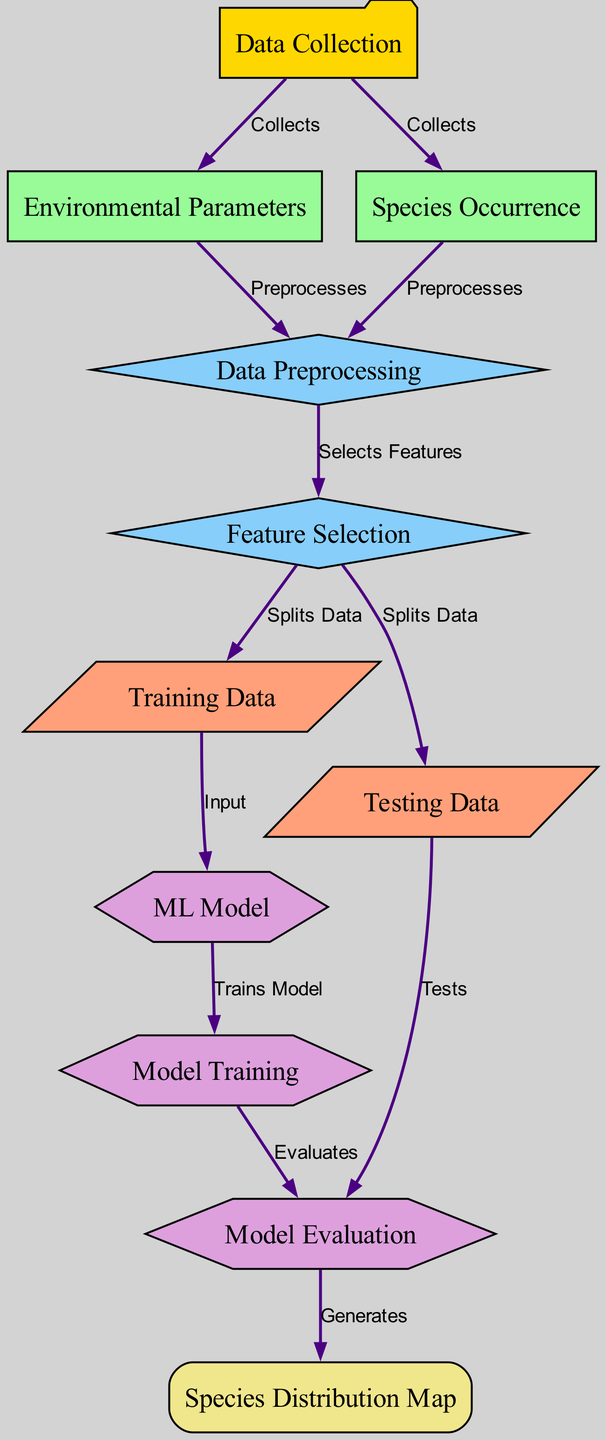What is the first step in the species distribution prediction process? According to the diagram, the first node is "Data Collection". This shows that the initial step involves gathering data before any analysis or modeling can occur.
Answer: Data Collection How many nodes are present in the diagram? By counting the distinct labeled nodes in the diagram, there are a total of 11 nodes. This includes both input and output nodes, along with various processing steps.
Answer: 11 What connects "Testing Data" to "Model Evaluation"? The diagram indicates that "Testing Data" is connected to "Model Evaluation" with an edge labeled "Tests", highlighting that this data is used to evaluate the model's performance.
Answer: Tests Which node generates the "Species Distribution Map"? The edge labeled "Generates" emanates from "Model Evaluation" and points to "Species Distribution Map", confirming that the map is the outcome of the model evaluation process.
Answer: Model Evaluation What processes follow after "Feature Selection"? The diagram shows that after "Feature Selection", data is split into "Training Data" and "Testing Data", indicating that both subsets are essential for training and validating the model, respectively.
Answer: Training Data and Testing Data Which node is responsible for training the machine learning model? The edge from "ML Model" to "Model Training" indicates that the model undergoes training at this node, making "Model Training" the specific function in which the ML model is trained using the provided data.
Answer: Model Training How many edges connect the various nodes in the diagram? By examining the connections between the nodes, it can be determined that there are 12 edges in total, representing the flow from one node to another within the process.
Answer: 12 What type of parameters are collected in the first step? The edges from "Data Collection" to both "Environmental Parameters" and "Species Occurrence" show that these types of parameters are gathered during the data collection phase.
Answer: Environmental Parameters and Species Occurrence What is the shape of the "Model Evaluation" node? The diagram indicates that "Model Evaluation" is designed as a hexagon, a specific shape used to represent this type of process or evaluation stage in machine learning workflows.
Answer: Hexagon 